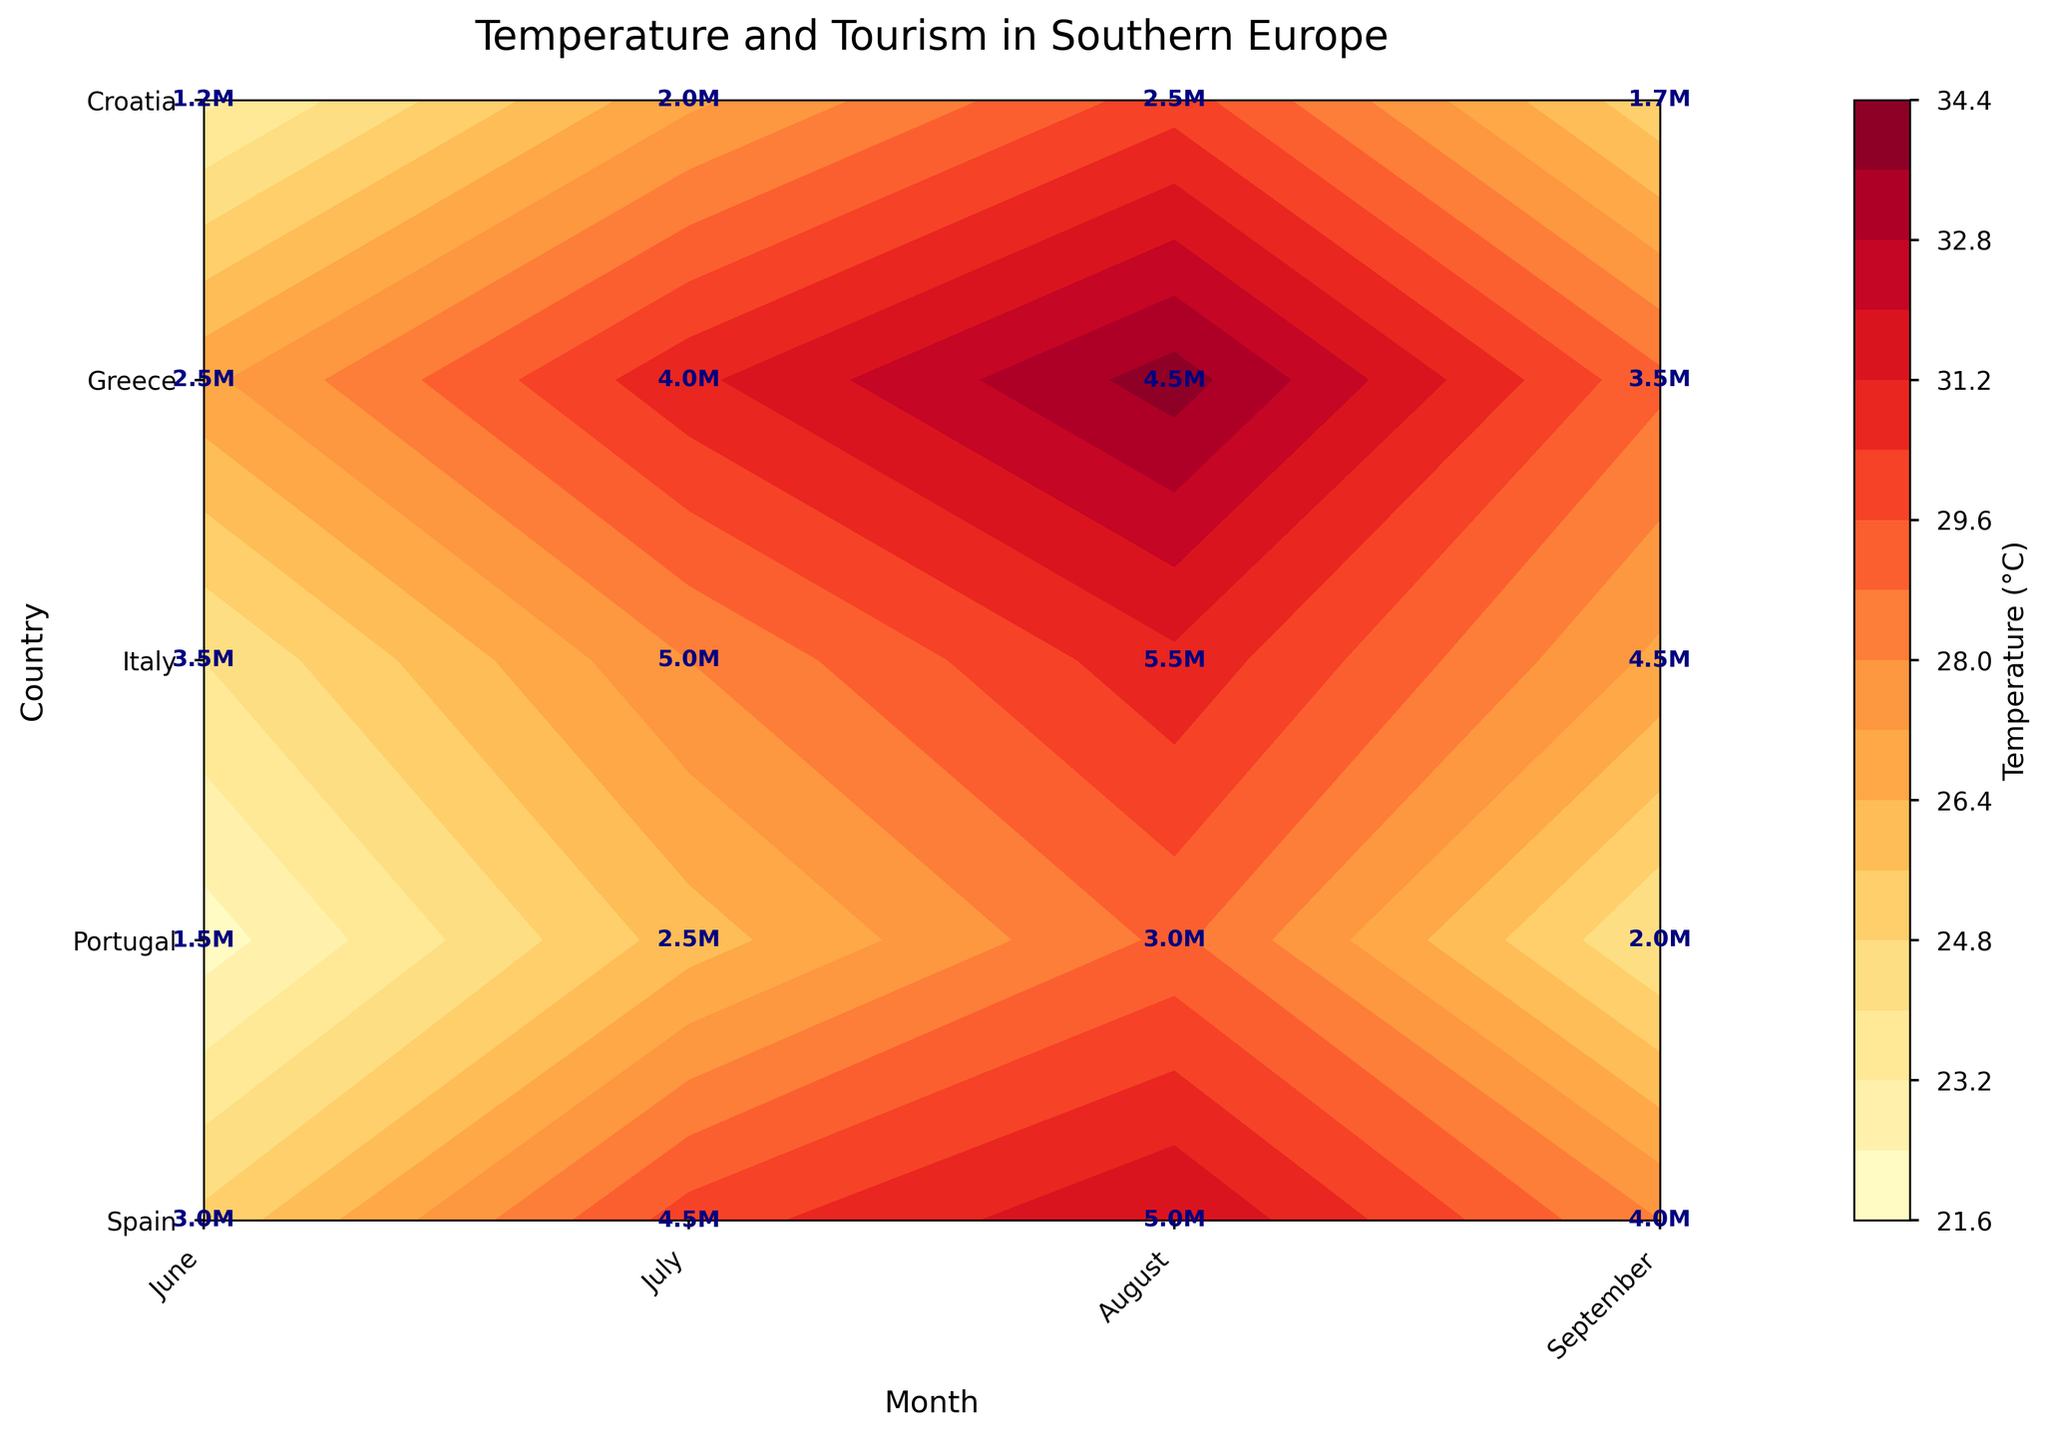What is the title of the figure? The title is located at the top center of the plot, serving as a summary of the content. In this case, it reads: "Temperature and Tourism in Southern Europe".
Answer: Temperature and Tourism in Southern Europe How is the 'Temperature (°C)' represented in the plot? The 'Temperature (°C)' is visualized using color gradients on a contour plot. Warmer colors (e.g., reds and oranges) indicate higher temperatures, while cooler colors (e.g., yellows) indicate lower temperatures. This color representation allows viewers to easily distinguish between different temperature levels across regions and months.
Answer: By color gradients on the contour plot Which country has the highest number of tourists in August? Look for the textual labels in the contour plot for the month of August. The highest number represented in August (34M) is found in Greece.
Answer: Greece What is the average temperature in July across all the countries? To find the average, identify the temperature values for July for each country: Spain (30°C), Portugal (26°C), Italy (28°C), Greece (31°C), and Croatia (27°C). Sum these values and divide by the number of countries: (30 + 26 + 28 + 31 + 27) / 5 = 28.4°C.
Answer: 28.4°C Comparing Greece and Portugal, which country sees a larger increase in the number of tourists from June to August? For Greece, the number of tourists increases from 2.5M in June to 4.5M in August, an increase of 2M. For Portugal, it increases from 1.5M in June to 3M in August, an increase of 1.5M. Hence, the increase is larger in Greece.
Answer: Greece How does the temperature in Italy change from June to September? Observe Italy's temperature values: June (24°C), July (28°C), August (31°C), and September (27°C). It increases from June to August and then decreases in September.
Answer: It increases and then decreases In which month does Spain have the highest number of tourists, and what is the corresponding temperature? For Spain, check each month for the highest tourist number. The highest is in August with 5M tourists, and the corresponding temperature for that month is 32°C.
Answer: August, 32°C Does Croatia ever have a higher number of tourists than Portugal? If so, when? Compare the tourist numbers for each month. In June, Portugal has 1.5M and Croatia 1.2M. In July, 2.5M vs 2M; in August, 3M vs 2.5M; in September, 2M vs 1.7M. At no point does Croatia surpass Portugal.
Answer: No What is the typical range of temperatures observed in Greece during the peak tourist season? The peak tourist season (June to August) for Greece shows temperatures: June (27°C), July (31°C), August (34°C). Thus, the range is from 27°C to 34°C.
Answer: 27°C to 34°C Which country experiences the smallest change in temperature from June to September, and what is that change? Calculate the temperature range for each country:
- Spain: 25°C to 32°C (change of 7°C)
- Portugal: 22°C to 29°C (change of 7°C)
- Italy: 24°C to 31°C (change of 7°C)
- Greece: 27°C to 34°C (change of 7°C)
- Croatia: 23°C to 30°C (change of 7°C)
Since all have the same change, the answer combines all.
Answer: Spain, Portugal, Italy, Greece, Croatia, 7°C 